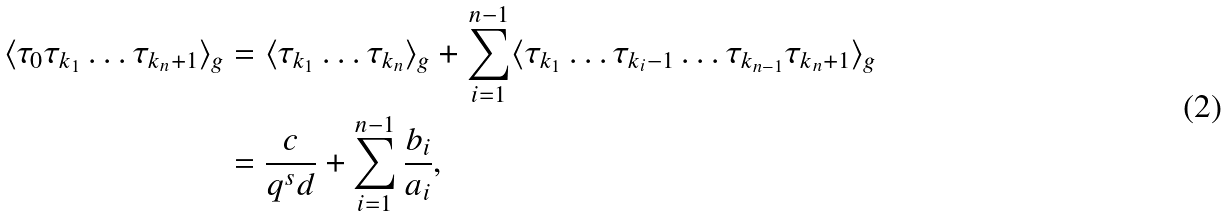Convert formula to latex. <formula><loc_0><loc_0><loc_500><loc_500>\langle \tau _ { 0 } \tau _ { k _ { 1 } } \dots \tau _ { k _ { n } + 1 } \rangle _ { g } & = \langle \tau _ { k _ { 1 } } \dots \tau _ { k _ { n } } \rangle _ { g } + \sum _ { i = 1 } ^ { n - 1 } \langle \tau _ { k _ { 1 } } \dots \tau _ { k _ { i } - 1 } \dots \tau _ { k _ { n - 1 } } \tau _ { k _ { n } + 1 } \rangle _ { g } \\ & = \frac { c } { q ^ { s } d } + \sum _ { i = 1 } ^ { n - 1 } \frac { b _ { i } } { a _ { i } } ,</formula> 